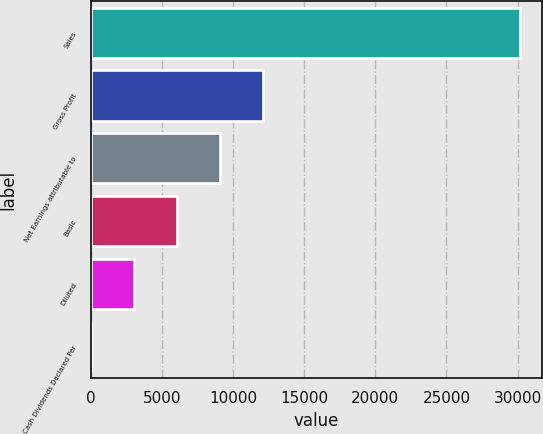Convert chart. <chart><loc_0><loc_0><loc_500><loc_500><bar_chart><fcel>Sales<fcel>Gross Profit<fcel>Net Earnings attributable to<fcel>Basic<fcel>Diluted<fcel>Cash Dividends Declared Per<nl><fcel>30184<fcel>12073.8<fcel>9055.44<fcel>6037.08<fcel>3018.72<fcel>0.36<nl></chart> 